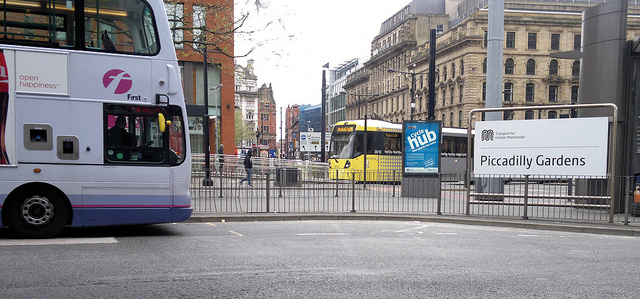How many buses are there? 2 